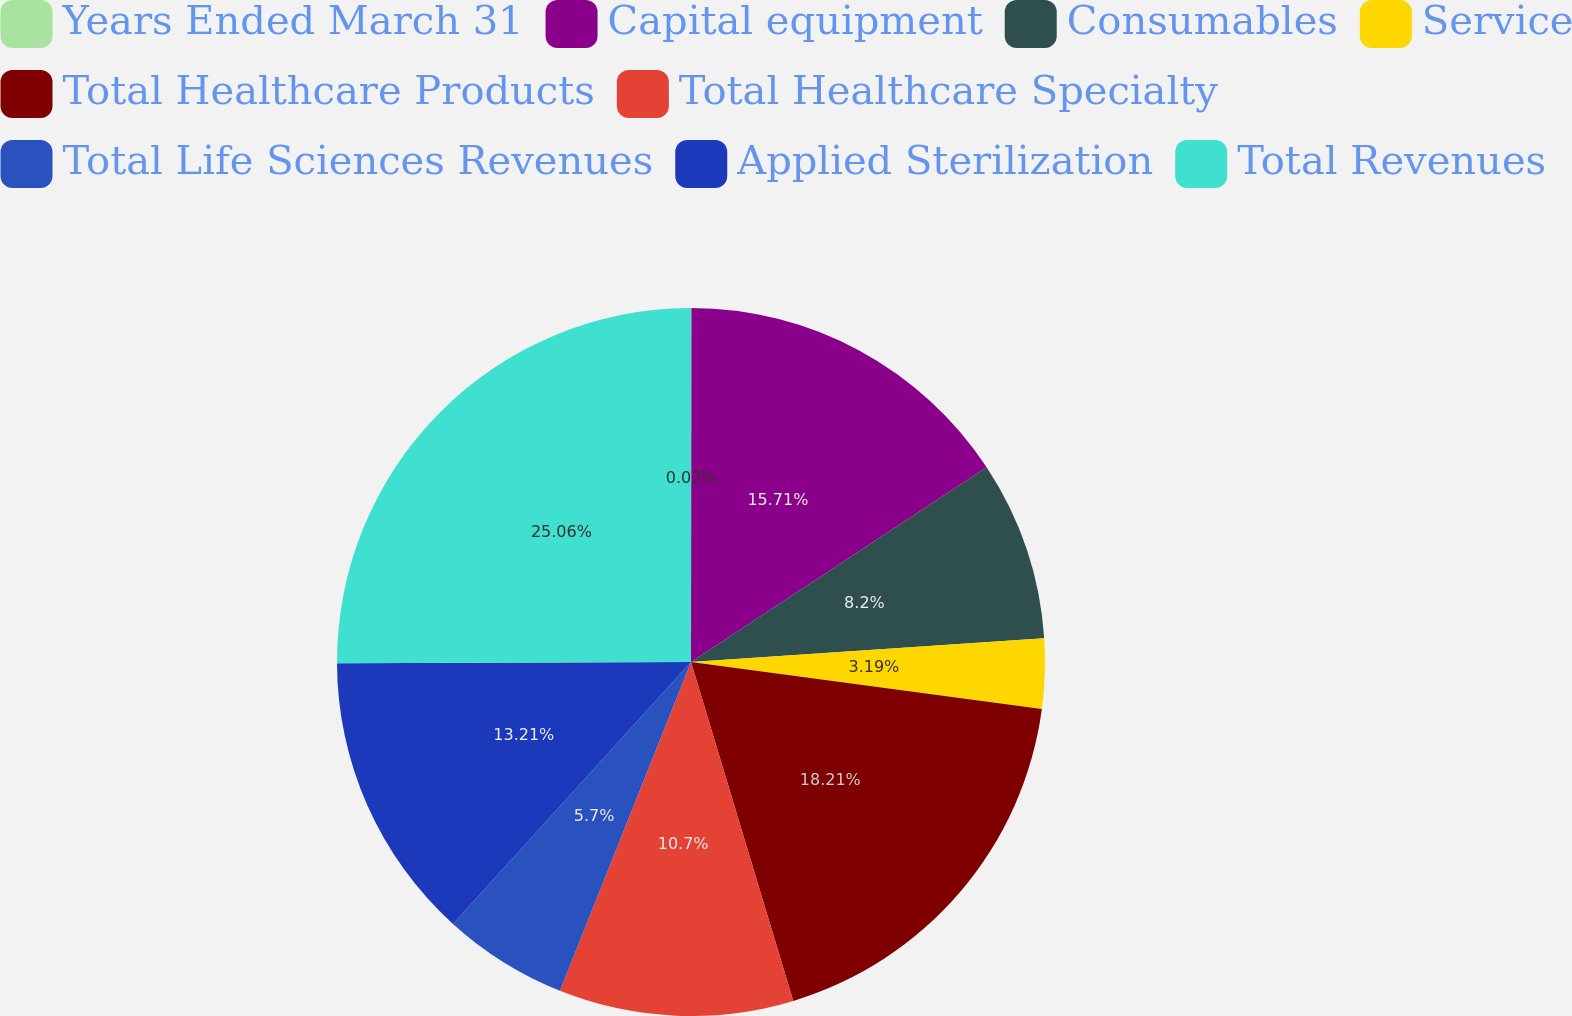<chart> <loc_0><loc_0><loc_500><loc_500><pie_chart><fcel>Years Ended March 31<fcel>Capital equipment<fcel>Consumables<fcel>Service<fcel>Total Healthcare Products<fcel>Total Healthcare Specialty<fcel>Total Life Sciences Revenues<fcel>Applied Sterilization<fcel>Total Revenues<nl><fcel>0.02%<fcel>15.71%<fcel>8.2%<fcel>3.19%<fcel>18.21%<fcel>10.7%<fcel>5.7%<fcel>13.21%<fcel>25.05%<nl></chart> 